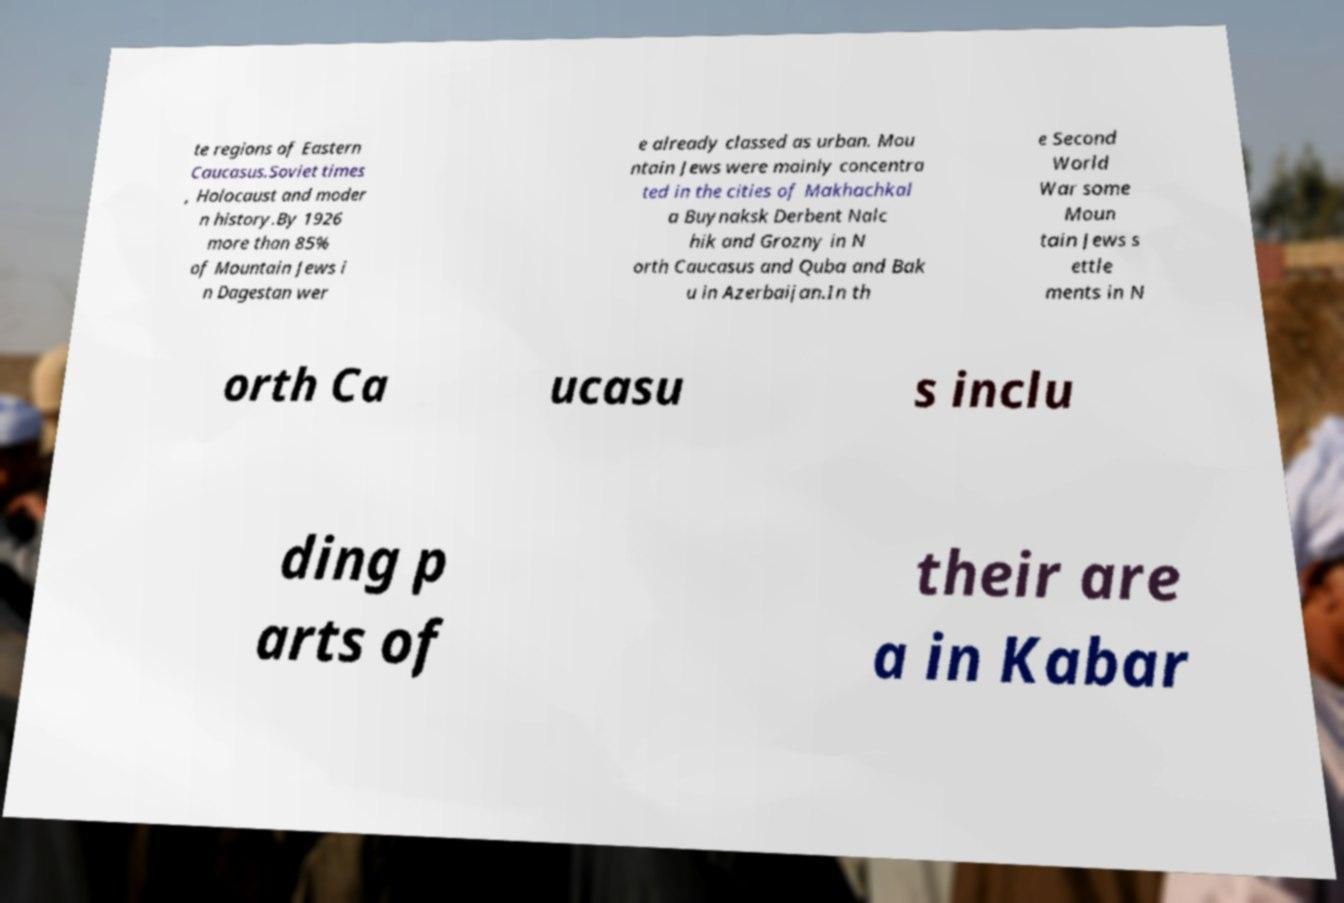I need the written content from this picture converted into text. Can you do that? te regions of Eastern Caucasus.Soviet times , Holocaust and moder n history.By 1926 more than 85% of Mountain Jews i n Dagestan wer e already classed as urban. Mou ntain Jews were mainly concentra ted in the cities of Makhachkal a Buynaksk Derbent Nalc hik and Grozny in N orth Caucasus and Quba and Bak u in Azerbaijan.In th e Second World War some Moun tain Jews s ettle ments in N orth Ca ucasu s inclu ding p arts of their are a in Kabar 